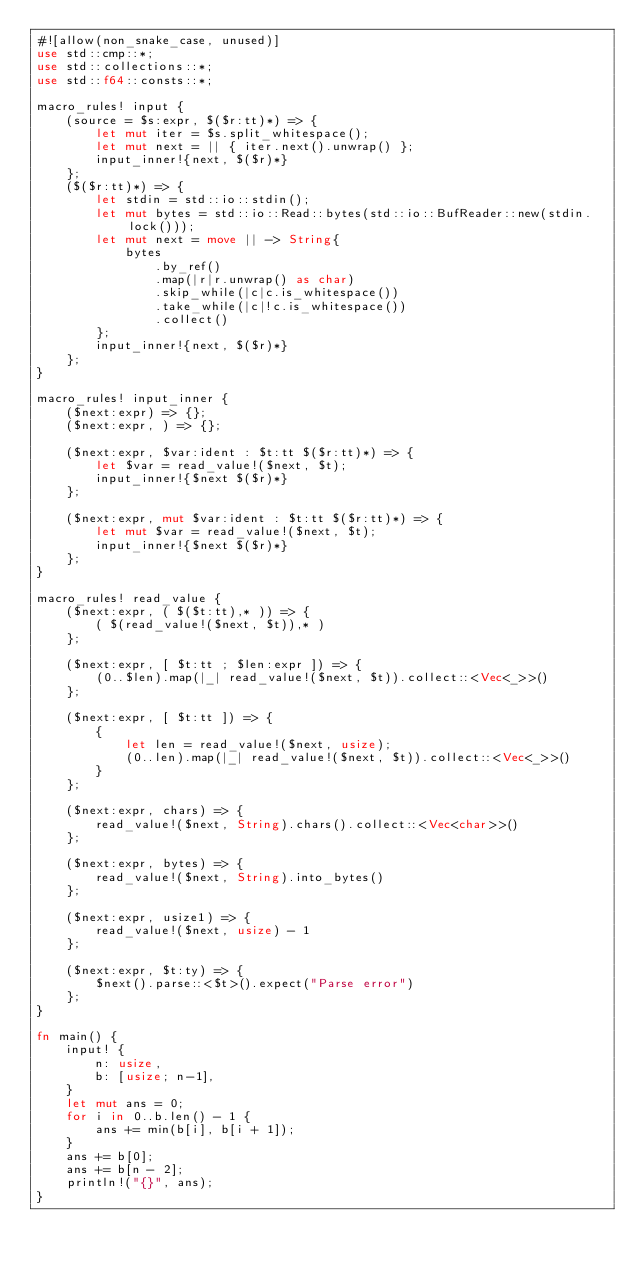Convert code to text. <code><loc_0><loc_0><loc_500><loc_500><_Rust_>#![allow(non_snake_case, unused)]
use std::cmp::*;
use std::collections::*;
use std::f64::consts::*;

macro_rules! input {
    (source = $s:expr, $($r:tt)*) => {
        let mut iter = $s.split_whitespace();
        let mut next = || { iter.next().unwrap() };
        input_inner!{next, $($r)*}
    };
    ($($r:tt)*) => {
        let stdin = std::io::stdin();
        let mut bytes = std::io::Read::bytes(std::io::BufReader::new(stdin.lock()));
        let mut next = move || -> String{
            bytes
                .by_ref()
                .map(|r|r.unwrap() as char)
                .skip_while(|c|c.is_whitespace())
                .take_while(|c|!c.is_whitespace())
                .collect()
        };
        input_inner!{next, $($r)*}
    };
}

macro_rules! input_inner {
    ($next:expr) => {};
    ($next:expr, ) => {};

    ($next:expr, $var:ident : $t:tt $($r:tt)*) => {
        let $var = read_value!($next, $t);
        input_inner!{$next $($r)*}
    };

    ($next:expr, mut $var:ident : $t:tt $($r:tt)*) => {
        let mut $var = read_value!($next, $t);
        input_inner!{$next $($r)*}
    };
}

macro_rules! read_value {
    ($next:expr, ( $($t:tt),* )) => {
        ( $(read_value!($next, $t)),* )
    };

    ($next:expr, [ $t:tt ; $len:expr ]) => {
        (0..$len).map(|_| read_value!($next, $t)).collect::<Vec<_>>()
    };

    ($next:expr, [ $t:tt ]) => {
        {
            let len = read_value!($next, usize);
            (0..len).map(|_| read_value!($next, $t)).collect::<Vec<_>>()
        }
    };

    ($next:expr, chars) => {
        read_value!($next, String).chars().collect::<Vec<char>>()
    };

    ($next:expr, bytes) => {
        read_value!($next, String).into_bytes()
    };

    ($next:expr, usize1) => {
        read_value!($next, usize) - 1
    };

    ($next:expr, $t:ty) => {
        $next().parse::<$t>().expect("Parse error")
    };
}

fn main() {
    input! {
        n: usize,
        b: [usize; n-1],
    }
    let mut ans = 0;
    for i in 0..b.len() - 1 {
        ans += min(b[i], b[i + 1]);
    }
    ans += b[0];
    ans += b[n - 2];
    println!("{}", ans);
}
</code> 